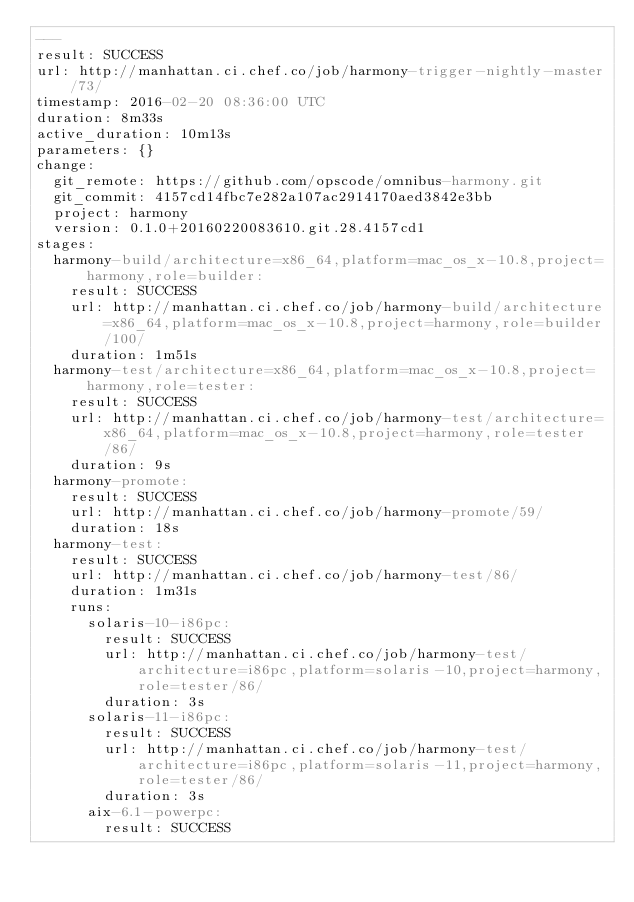Convert code to text. <code><loc_0><loc_0><loc_500><loc_500><_YAML_>---
result: SUCCESS
url: http://manhattan.ci.chef.co/job/harmony-trigger-nightly-master/73/
timestamp: 2016-02-20 08:36:00 UTC
duration: 8m33s
active_duration: 10m13s
parameters: {}
change:
  git_remote: https://github.com/opscode/omnibus-harmony.git
  git_commit: 4157cd14fbc7e282a107ac2914170aed3842e3bb
  project: harmony
  version: 0.1.0+20160220083610.git.28.4157cd1
stages:
  harmony-build/architecture=x86_64,platform=mac_os_x-10.8,project=harmony,role=builder:
    result: SUCCESS
    url: http://manhattan.ci.chef.co/job/harmony-build/architecture=x86_64,platform=mac_os_x-10.8,project=harmony,role=builder/100/
    duration: 1m51s
  harmony-test/architecture=x86_64,platform=mac_os_x-10.8,project=harmony,role=tester:
    result: SUCCESS
    url: http://manhattan.ci.chef.co/job/harmony-test/architecture=x86_64,platform=mac_os_x-10.8,project=harmony,role=tester/86/
    duration: 9s
  harmony-promote:
    result: SUCCESS
    url: http://manhattan.ci.chef.co/job/harmony-promote/59/
    duration: 18s
  harmony-test:
    result: SUCCESS
    url: http://manhattan.ci.chef.co/job/harmony-test/86/
    duration: 1m31s
    runs:
      solaris-10-i86pc:
        result: SUCCESS
        url: http://manhattan.ci.chef.co/job/harmony-test/architecture=i86pc,platform=solaris-10,project=harmony,role=tester/86/
        duration: 3s
      solaris-11-i86pc:
        result: SUCCESS
        url: http://manhattan.ci.chef.co/job/harmony-test/architecture=i86pc,platform=solaris-11,project=harmony,role=tester/86/
        duration: 3s
      aix-6.1-powerpc:
        result: SUCCESS</code> 